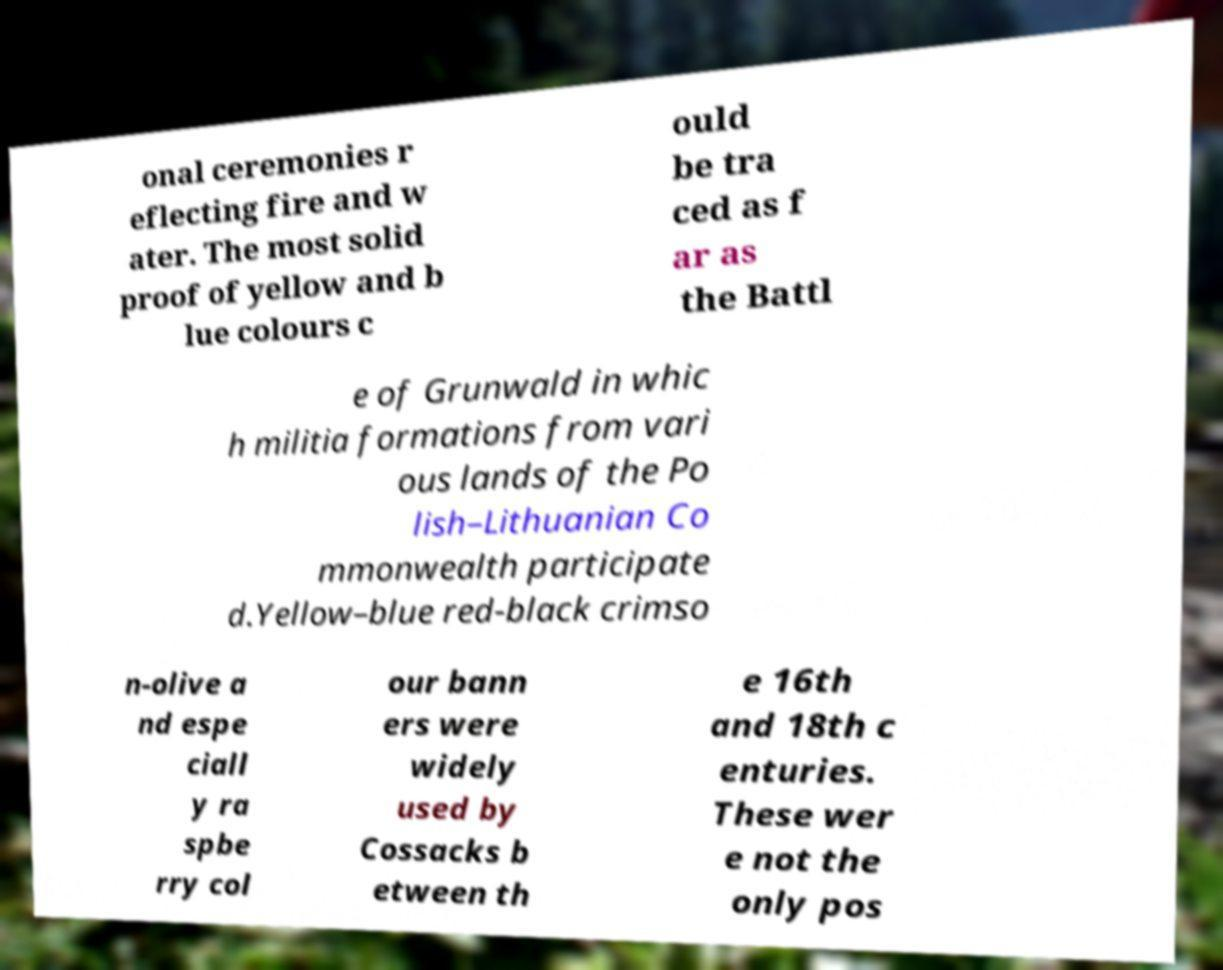There's text embedded in this image that I need extracted. Can you transcribe it verbatim? onal ceremonies r eflecting fire and w ater. The most solid proof of yellow and b lue colours c ould be tra ced as f ar as the Battl e of Grunwald in whic h militia formations from vari ous lands of the Po lish–Lithuanian Co mmonwealth participate d.Yellow–blue red-black crimso n-olive a nd espe ciall y ra spbe rry col our bann ers were widely used by Cossacks b etween th e 16th and 18th c enturies. These wer e not the only pos 